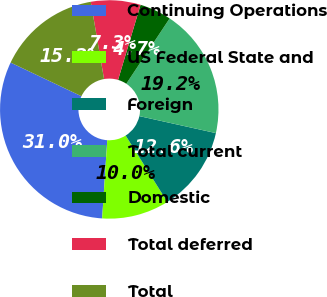Convert chart. <chart><loc_0><loc_0><loc_500><loc_500><pie_chart><fcel>Continuing Operations<fcel>US Federal State and<fcel>Foreign<fcel>Total current<fcel>Domestic<fcel>Total deferred<fcel>Total<nl><fcel>31.02%<fcel>9.96%<fcel>12.6%<fcel>19.15%<fcel>4.7%<fcel>7.33%<fcel>15.23%<nl></chart> 